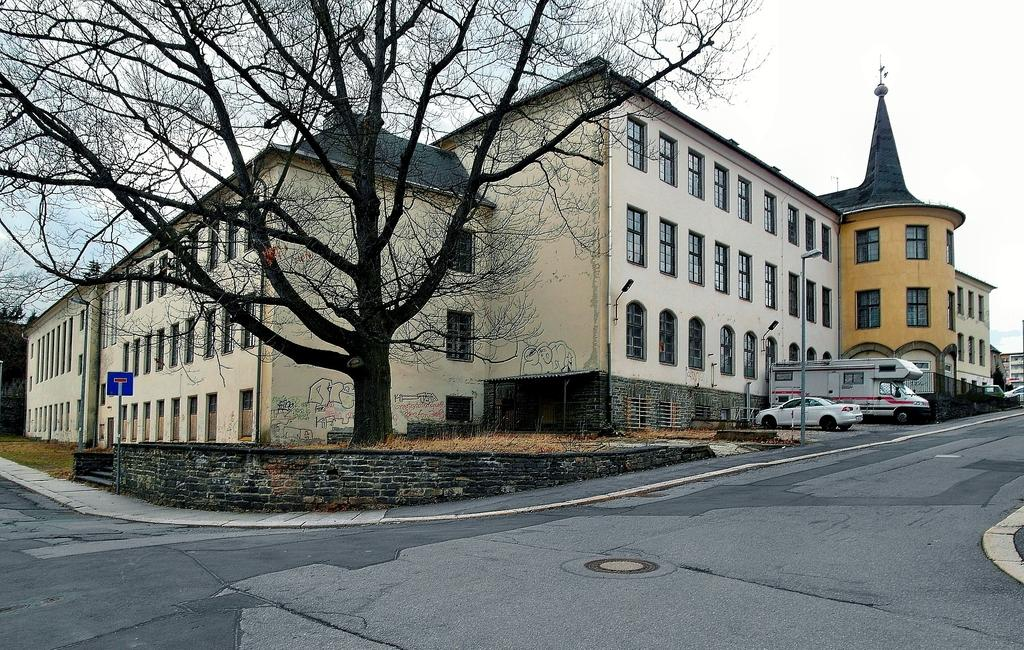Where was the picture taken? The picture was taken outside a building. What can be seen in front of the building? There are vehicles parked in front of the building. What natural element is present in the image? There is a tree in the image. How would you describe the weather based on the image? The sky is clear, suggesting good weather. What is visible in the foreground of the image? There is a road in the foreground of the image. What type of beast is being carried by the porter in the image? There is no porter or beast present in the image. What kind of flesh can be seen hanging from the tree in the image? There is no flesh hanging from the tree in the image; it is a regular tree with leaves. 